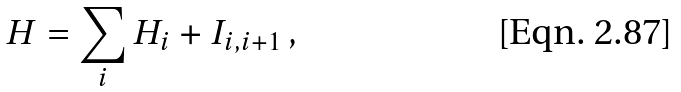<formula> <loc_0><loc_0><loc_500><loc_500>H = \sum _ { i } H _ { i } + I _ { i , i + 1 } \, ,</formula> 